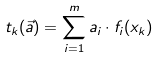Convert formula to latex. <formula><loc_0><loc_0><loc_500><loc_500>t _ { k } ( \vec { a } ) = \sum _ { i = 1 } ^ { m } a _ { i } \cdot f _ { i } ( x _ { k } )</formula> 